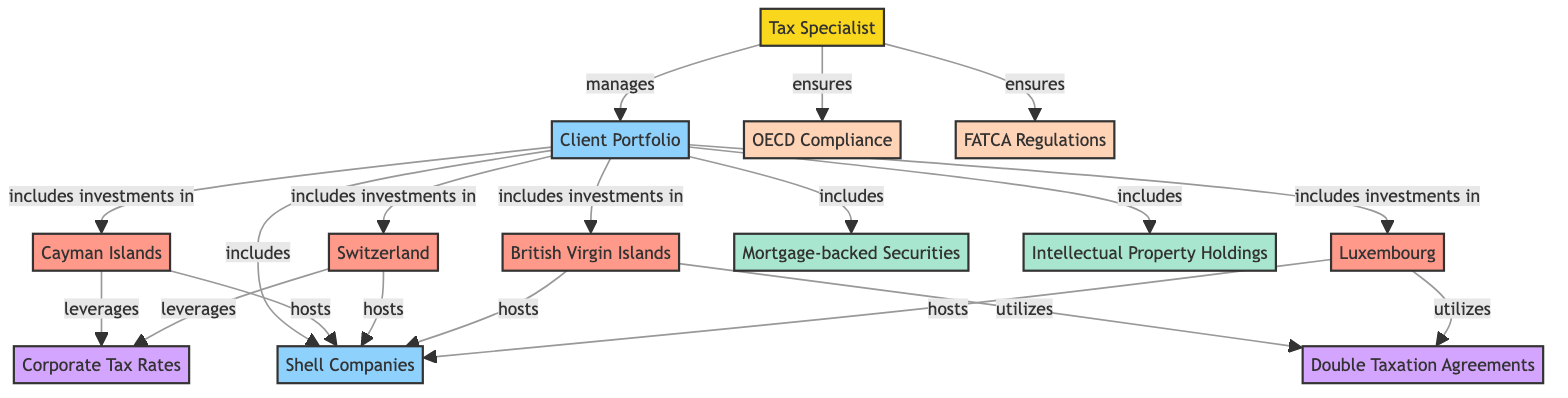What is the total number of nodes in the diagram? The diagram contains 13 nodes, which include the Tax Specialist, Client Portfolio, various jurisdictions, investment types, compliance regulations, and attributes.
Answer: 13 Which jurisdiction is linked to corporate tax rates? The Cayman Islands and Switzerland are both linked to Corporate Tax Rates as they leverage this attribute.
Answer: Cayman Islands, Switzerland How many investments does the Client Portfolio include? The Client Portfolio includes three types of investments: Mortgage-backed Securities, Intellectual Property Holdings, and Shell Companies.
Answer: 3 What type of compliance does the Tax Specialist ensure? The Tax Specialist ensures compliance with both OECD Compliance and FATCA Regulations.
Answer: OECD Compliance, FATCA Regulations Which jurisdiction utilizes Double Taxation Agreements? The British Virgin Islands and Luxembourg are two jurisdictions that utilize Double Taxation Agreements in managing their investments.
Answer: British Virgin Islands, Luxembourg Which investment type is hosted by every jurisdiction in the diagram? All jurisdictions listed in the diagram host Shell Companies, indicating a commonality among them in this regard.
Answer: Shell Companies What is the relationship between the Client Portfolio and the jurisdictions? The Client Portfolio includes investments in four jurisdictions: Cayman Islands, Switzerland, British Virgin Islands, and Luxembourg, showing a broad international investment strategy.
Answer: includes investments in How many edges are connecting the Tax Specialist to other nodes? The Tax Specialist has a total of three edges connecting to other nodes, managing the Client Portfolio and ensuring compliance with regulatory requirements.
Answer: 3 Which nodes are classified as attributes in the diagram? The attributes represented in the diagram are Corporate Tax Rates and Double Taxation Agreements, which are important in the context of international investments.
Answer: Corporate Tax Rates, Double Taxation Agreements 